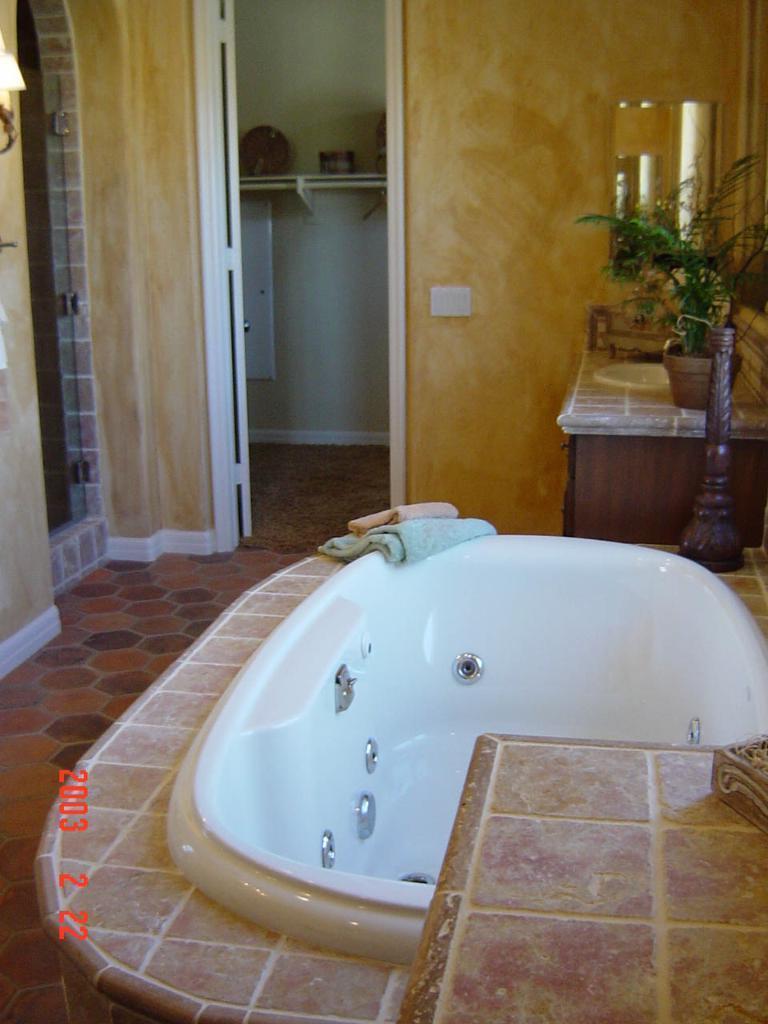Can you describe this image briefly? In this image here there is a bathtub. These are towels. This is the entrance. In the country there is a sink, planter pot. This is a mirror. 